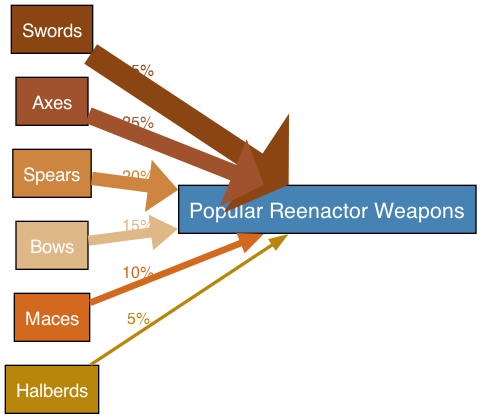What is the most popular weapon type among reenactors? The edge labeled with the highest percentage coming from a weapon node indicates its popularity. In this case, the sword node has a link to group A with a value of 35%. Thus, the most popular weapon type is the sword.
Answer: sword How many weapon types are listed in the diagram? By counting the individual nodes in the diagram, there are six distinct weapon types represented: swords, axes, spears, bows, maces, and halberds. Therefore, the total number of weapon types is six.
Answer: six Which weapon types have values greater than or equal to 20%? To find which weapon types are favored among reenactors, we look for nodes with outgoing links to group A that have values of 20% or higher. The sword (35%), axe (25%), and spear (20%) are the weapon types that meet this criterion.
Answer: sword, axe, spear What percentage of reenactors prefer maces? The value ascribed to the mace node indicates its preference level among reenactors. The edge connecting the mace node to group A has a value of 10%, which signifies that 10% of reenactors prefer maces.
Answer: 10% Which weapon has the lowest popularity among reenactors? To determine the least popular weapon type, we inspect the percentages attached to each weapon type. The halberd node, which links to group A with a value of 5%, indicates that it is the least popular weapon among reenactors.
Answer: halberds What is the total percentage of all weapon types combined? By adding the values of all the weapon types linked to group A from the diagram, we get: 35% (sword) + 25% (axe) + 20% (spear) + 15% (bow) + 10% (mace) + 5% (halberd) = 110%. Thus, the total percentage is 110%.
Answer: 110% 